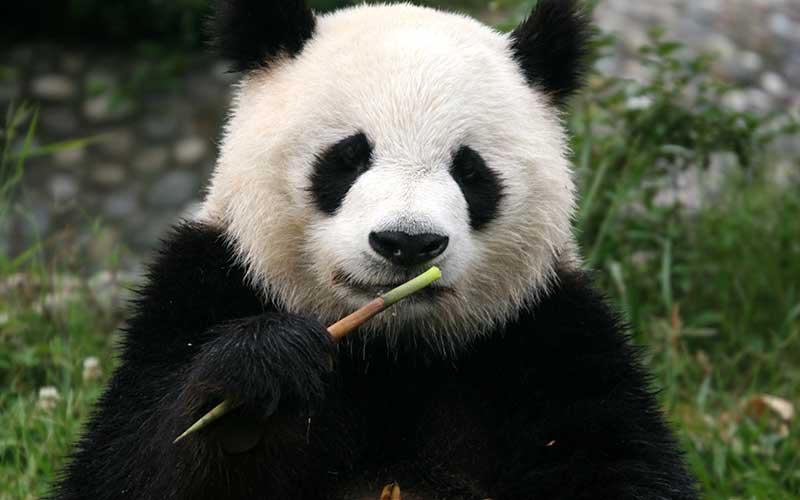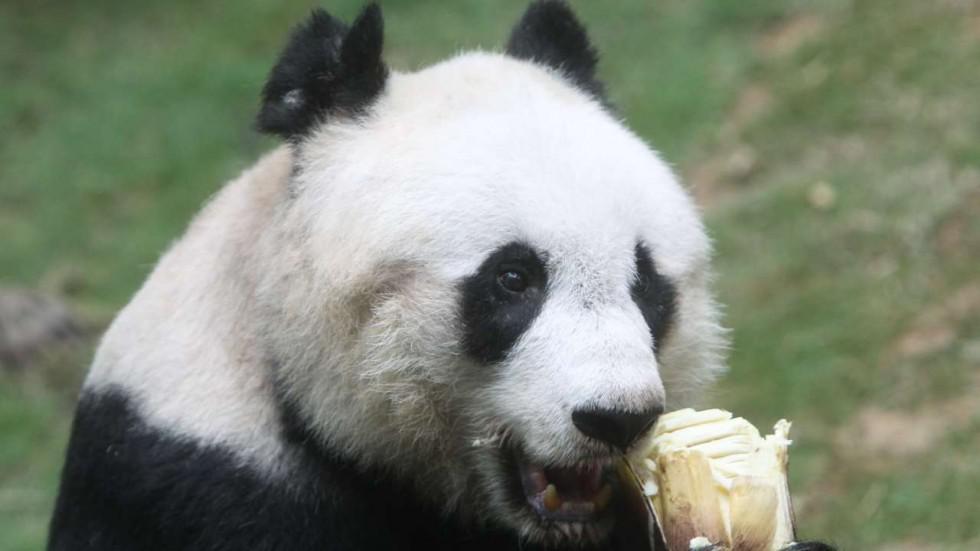The first image is the image on the left, the second image is the image on the right. Examine the images to the left and right. Is the description "The right image contains two pandas in close contact." accurate? Answer yes or no. No. The first image is the image on the left, the second image is the image on the right. Analyze the images presented: Is the assertion "There is at least one pair of pandas hugging." valid? Answer yes or no. No. 